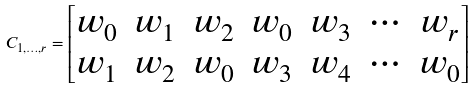Convert formula to latex. <formula><loc_0><loc_0><loc_500><loc_500>C _ { 1 , \dots , r } = \begin{bmatrix} w _ { 0 } & w _ { 1 } & w _ { 2 } & w _ { 0 } & w _ { 3 } & \cdots & w _ { r } \\ w _ { 1 } & w _ { 2 } & w _ { 0 } & w _ { 3 } & w _ { 4 } & \cdots & w _ { 0 } \end{bmatrix}</formula> 